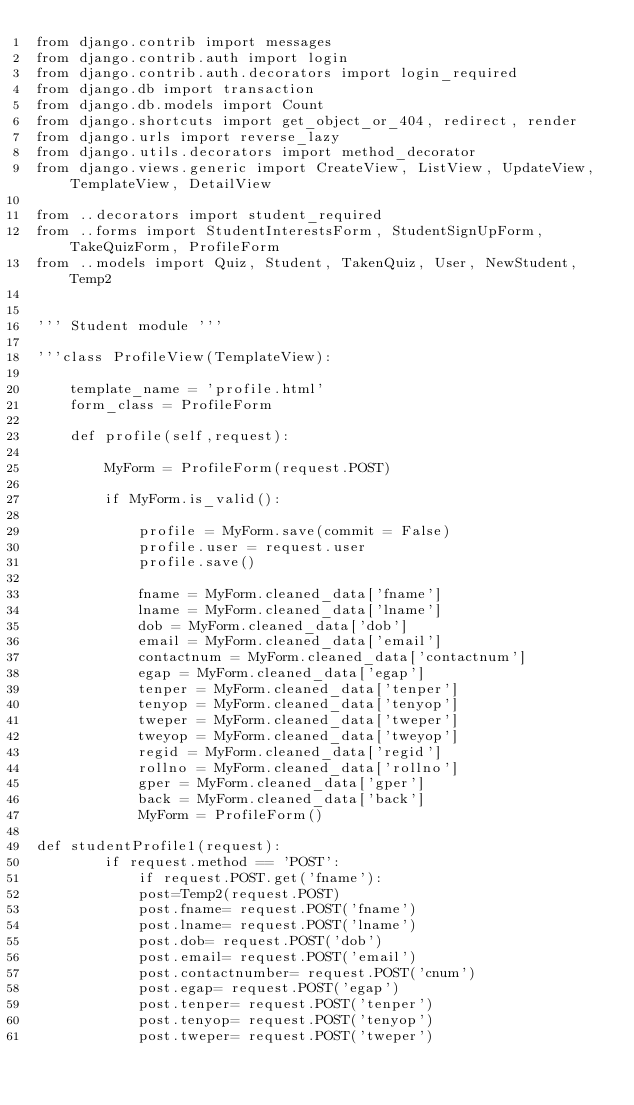<code> <loc_0><loc_0><loc_500><loc_500><_Python_>from django.contrib import messages
from django.contrib.auth import login
from django.contrib.auth.decorators import login_required
from django.db import transaction
from django.db.models import Count
from django.shortcuts import get_object_or_404, redirect, render
from django.urls import reverse_lazy
from django.utils.decorators import method_decorator
from django.views.generic import CreateView, ListView, UpdateView, TemplateView, DetailView

from ..decorators import student_required
from ..forms import StudentInterestsForm, StudentSignUpForm, TakeQuizForm, ProfileForm
from ..models import Quiz, Student, TakenQuiz, User, NewStudent, Temp2


''' Student module '''

'''class ProfileView(TemplateView):

    template_name = 'profile.html'
    form_class = ProfileForm

    def profile(self,request):
        
        MyForm = ProfileForm(request.POST)
      
        if MyForm.is_valid():

            profile = MyForm.save(commit = False)
            profile.user = request.user
            profile.save()

            fname = MyForm.cleaned_data['fname']
            lname = MyForm.cleaned_data['lname']
            dob = MyForm.cleaned_data['dob']
            email = MyForm.cleaned_data['email']
            contactnum = MyForm.cleaned_data['contactnum']
            egap = MyForm.cleaned_data['egap']
            tenper = MyForm.cleaned_data['tenper']
            tenyop = MyForm.cleaned_data['tenyop']
            tweper = MyForm.cleaned_data['tweper']
            tweyop = MyForm.cleaned_data['tweyop']
            regid = MyForm.cleaned_data['regid']
            rollno = MyForm.cleaned_data['rollno']
            gper = MyForm.cleaned_data['gper']
            back = MyForm.cleaned_data['back']
            MyForm = ProfileForm()

def studentProfile1(request):
        if request.method == 'POST':
            if request.POST.get('fname'):
            post=Temp2(request.POST)
            post.fname= request.POST('fname')
            post.lname= request.POST('lname')
            post.dob= request.POST('dob')
            post.email= request.POST('email')
            post.contactnumber= request.POST('cnum')
            post.egap= request.POST('egap')
            post.tenper= request.POST('tenper')
            post.tenyop= request.POST('tenyop')
            post.tweper= request.POST('tweper')</code> 